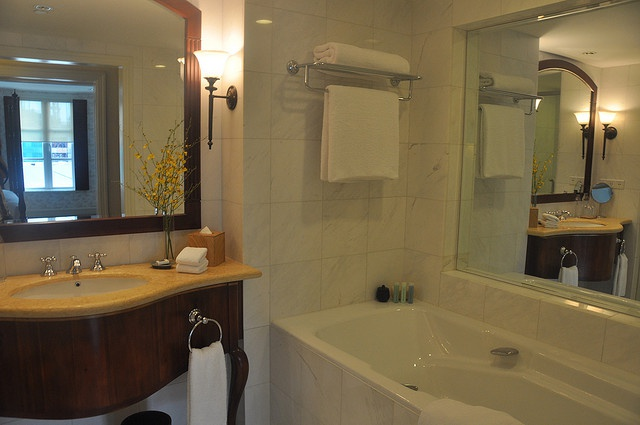Describe the objects in this image and their specific colors. I can see sink in gray, olive, and tan tones and vase in gray, black, and maroon tones in this image. 